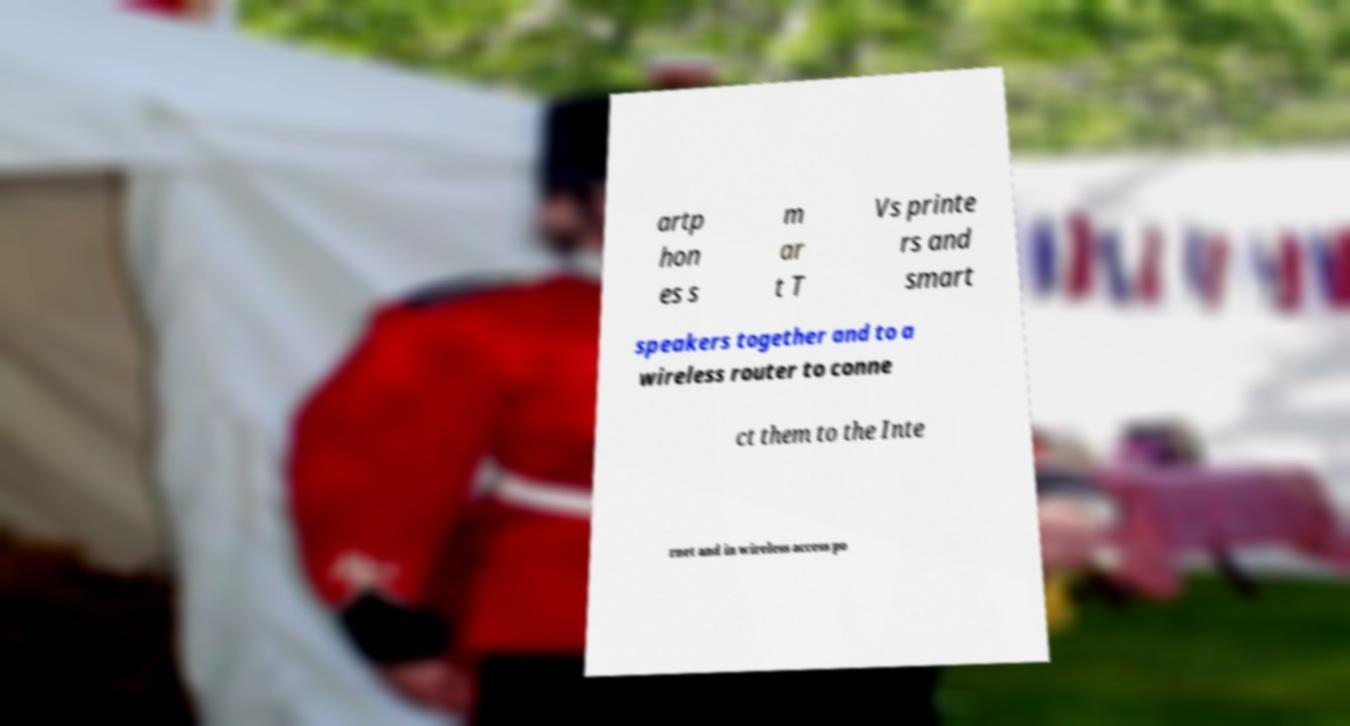Please identify and transcribe the text found in this image. artp hon es s m ar t T Vs printe rs and smart speakers together and to a wireless router to conne ct them to the Inte rnet and in wireless access po 